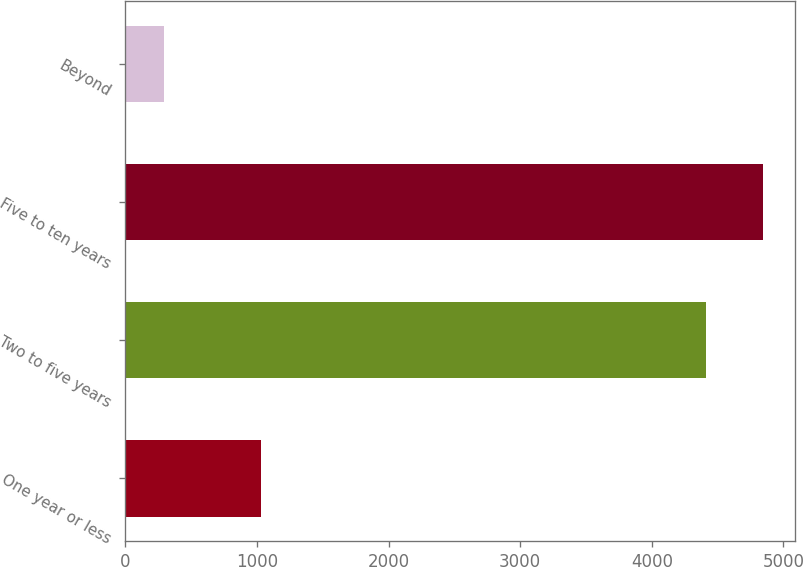<chart> <loc_0><loc_0><loc_500><loc_500><bar_chart><fcel>One year or less<fcel>Two to five years<fcel>Five to ten years<fcel>Beyond<nl><fcel>1028<fcel>4411<fcel>4842.6<fcel>292<nl></chart> 